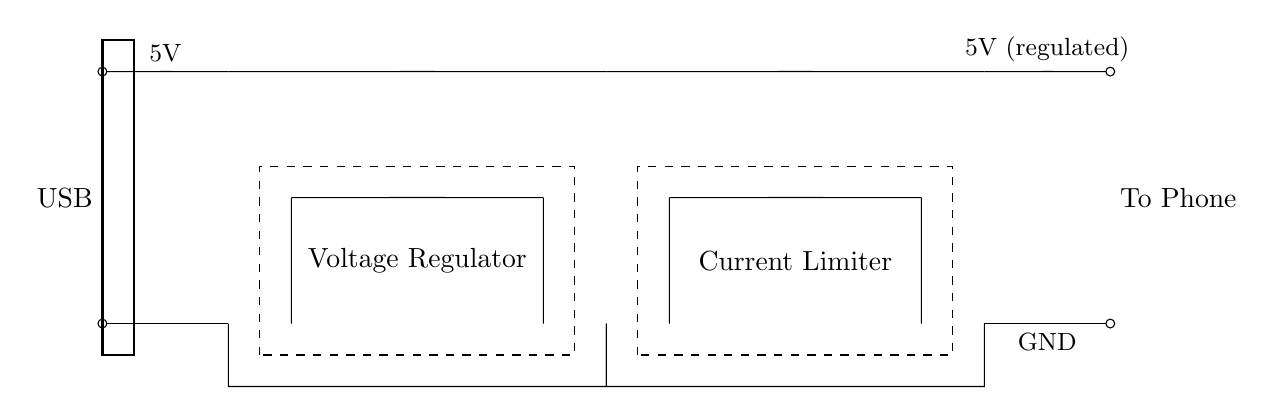What type of power source is used in this circuit? The circuit uses a USB power source, as indicated by the label "USB" at the input.
Answer: USB What is the purpose of the voltage regulator in this circuit? The voltage regulator ensures a stable output voltage of 5V, which is necessary for charging devices safely.
Answer: Regulate voltage What component is responsible for limiting the current in this circuit? The current limiter is the component that prevents excessive current from damaging the connected device by controlling the current flow.
Answer: Current limiter What is the output voltage of this charger circuit? The output voltage, as shown in the diagram, is regulated to remain at 5V, suitable for charging most phones.
Answer: 5V How many main components are shown in this circuit diagram? The circuit diagram displays two main components: a voltage regulator and a current limiter, both serving essential functions in the charging process.
Answer: Two What happens if the current exceeds the limit set by the current limiter? If the current exceeds the limit, the current limiter will decrease the output current to protect the phone from damage, ensuring safe operation.
Answer: Reduces output current What allows the circuit to connect to a phone? The circuit connects to a phone through the output leads marked "To Phone," which provide the necessary voltage and current for charging.
Answer: Output leads 